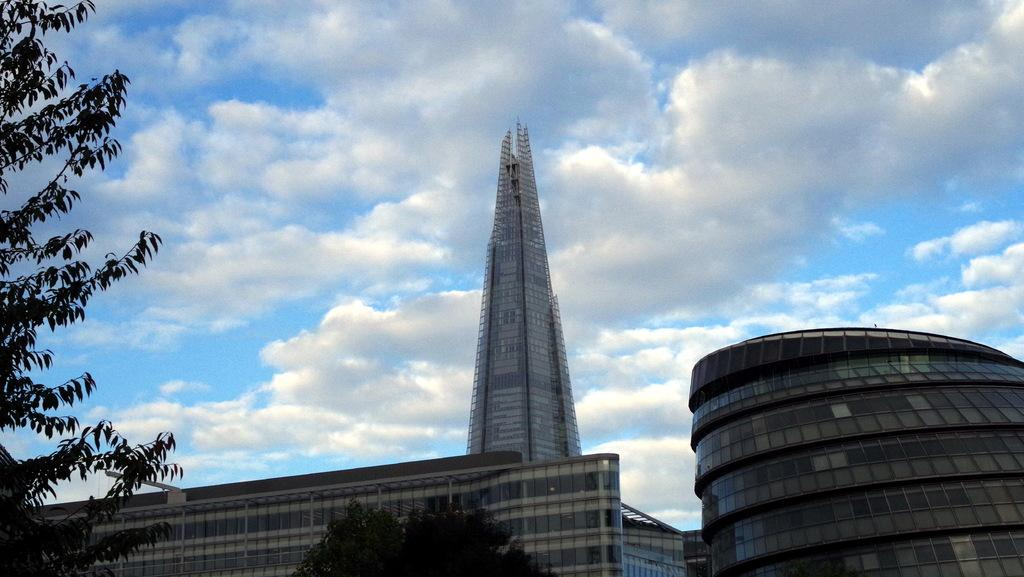What type of structures are present in the image? There are buildings in the image. What can be seen in front of the buildings? There are trees in front of the buildings. What is visible in the background of the image? The sky is visible in the background of the image. What type of jar is visible on top of the buildings in the image? There is no jar present on top of the buildings in the image. How many tickets can be seen hanging from the trees in the image? There are no tickets hanging from the trees in the image. 